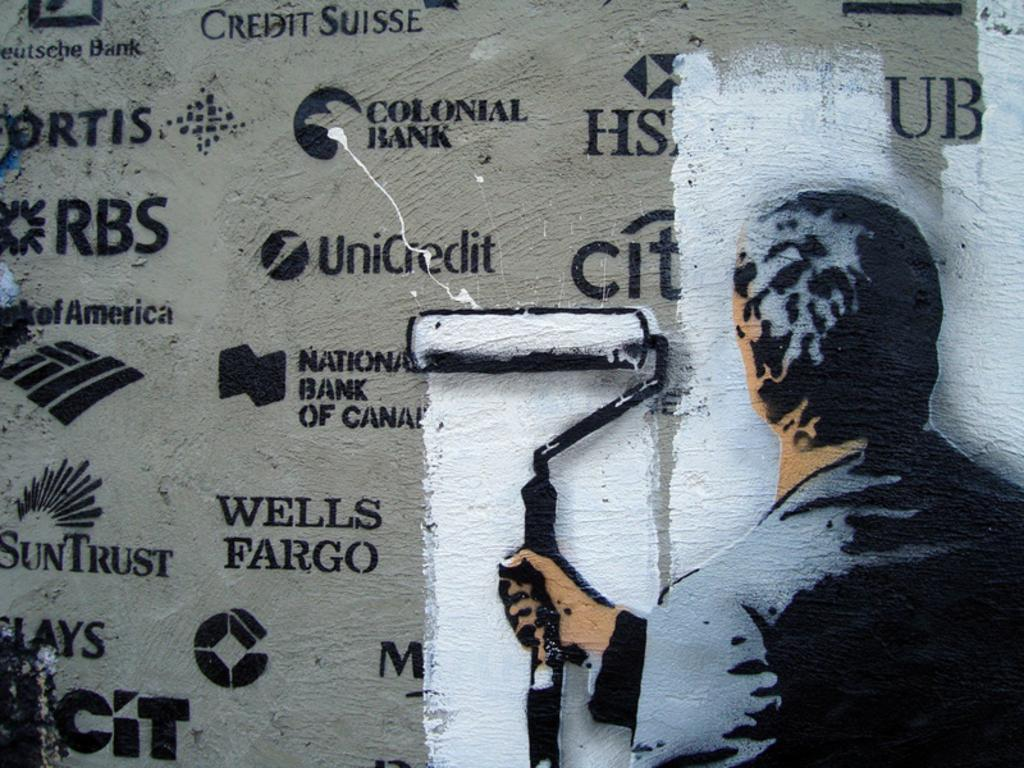Provide a one-sentence caption for the provided image. Man painting over a wall full of logos including Wells Fargo. 